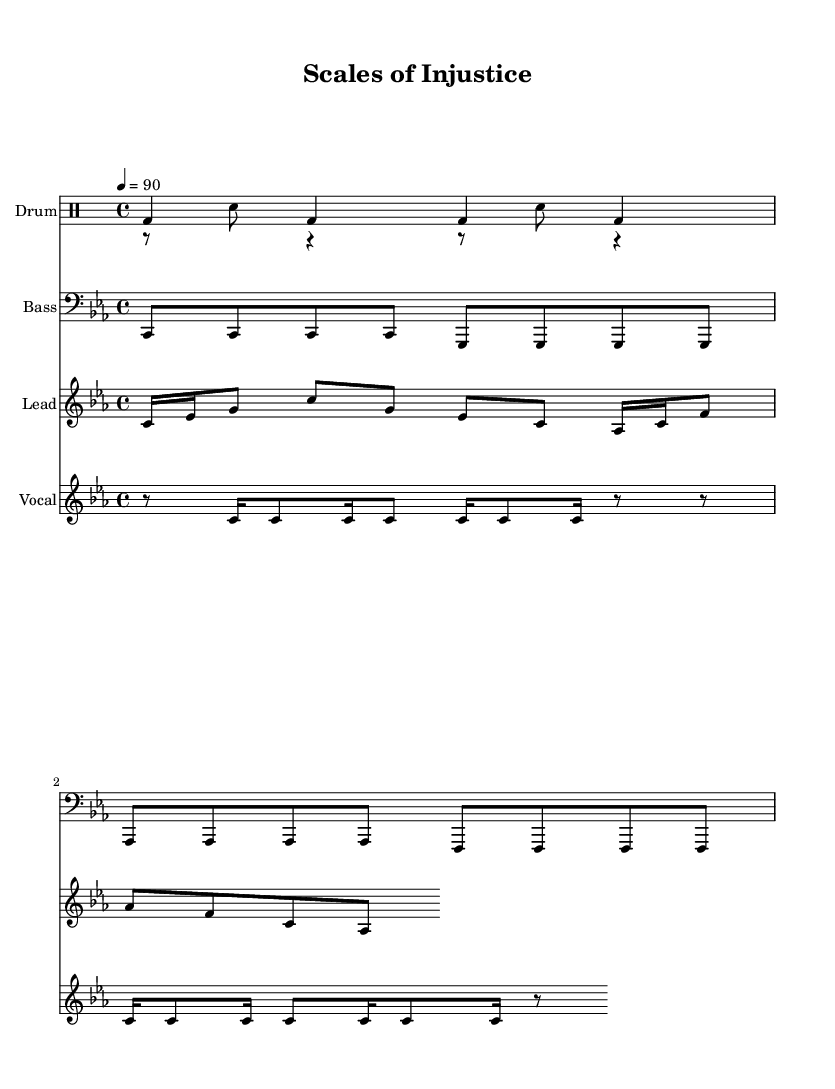What is the key signature of this music? The key signature is indicated at the start of the score. The presence of three flat signs indicates that the key is C minor.
Answer: C minor What is the time signature of the composition? The time signature is found at the beginning of the score. It shows that there are four beats in each measure, represented as 4/4.
Answer: 4/4 What is the tempo marking of the piece? The tempo marking is given as "4 = 90". This indicates the speed at which the piece should be played, specifically 90 beats per minute.
Answer: 90 How many drum patterns are present in the score? By reviewing the score, I can count two distinct drum patterns, one labeled "Upper" and the other "Lower".
Answer: Two What is the main lyrical theme of the rap? The lyrics explore themes of corruption and uncovering lies within the justice system, as indicated by the words in the verse.
Answer: Corruption What is the compositional structure of the vocal melody? The vocal melody is composed in a repeating rhythmic and melodic pattern, with each phrase structured using eighth, sixteenth notes, and rests. This creates a consistent rhythmic feel.
Answer: Repeating What do the lyrics specifically reveal about the subject matter? The lyrics reveal an investigative angle focused on digging deep to expose the truth, highlighting the flaws in the justice system.
Answer: Exposing truth 